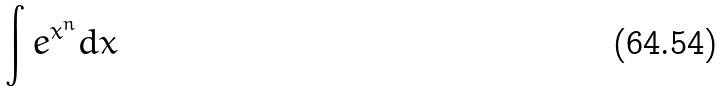Convert formula to latex. <formula><loc_0><loc_0><loc_500><loc_500>\int e ^ { x ^ { n } } d x</formula> 